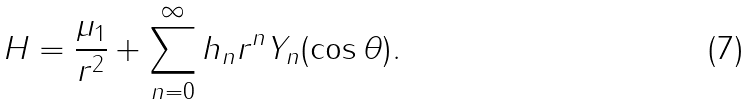Convert formula to latex. <formula><loc_0><loc_0><loc_500><loc_500>H = \frac { \mu _ { 1 } } { r ^ { 2 } } + \sum _ { n = 0 } ^ { \infty } h _ { n } r ^ { n } Y _ { n } ( \cos \theta ) .</formula> 